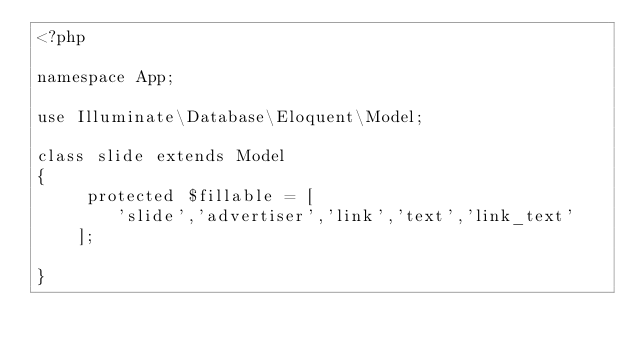<code> <loc_0><loc_0><loc_500><loc_500><_PHP_><?php

namespace App;

use Illuminate\Database\Eloquent\Model;

class slide extends Model
{
     protected $fillable = [
        'slide','advertiser','link','text','link_text'
    ];

}
</code> 